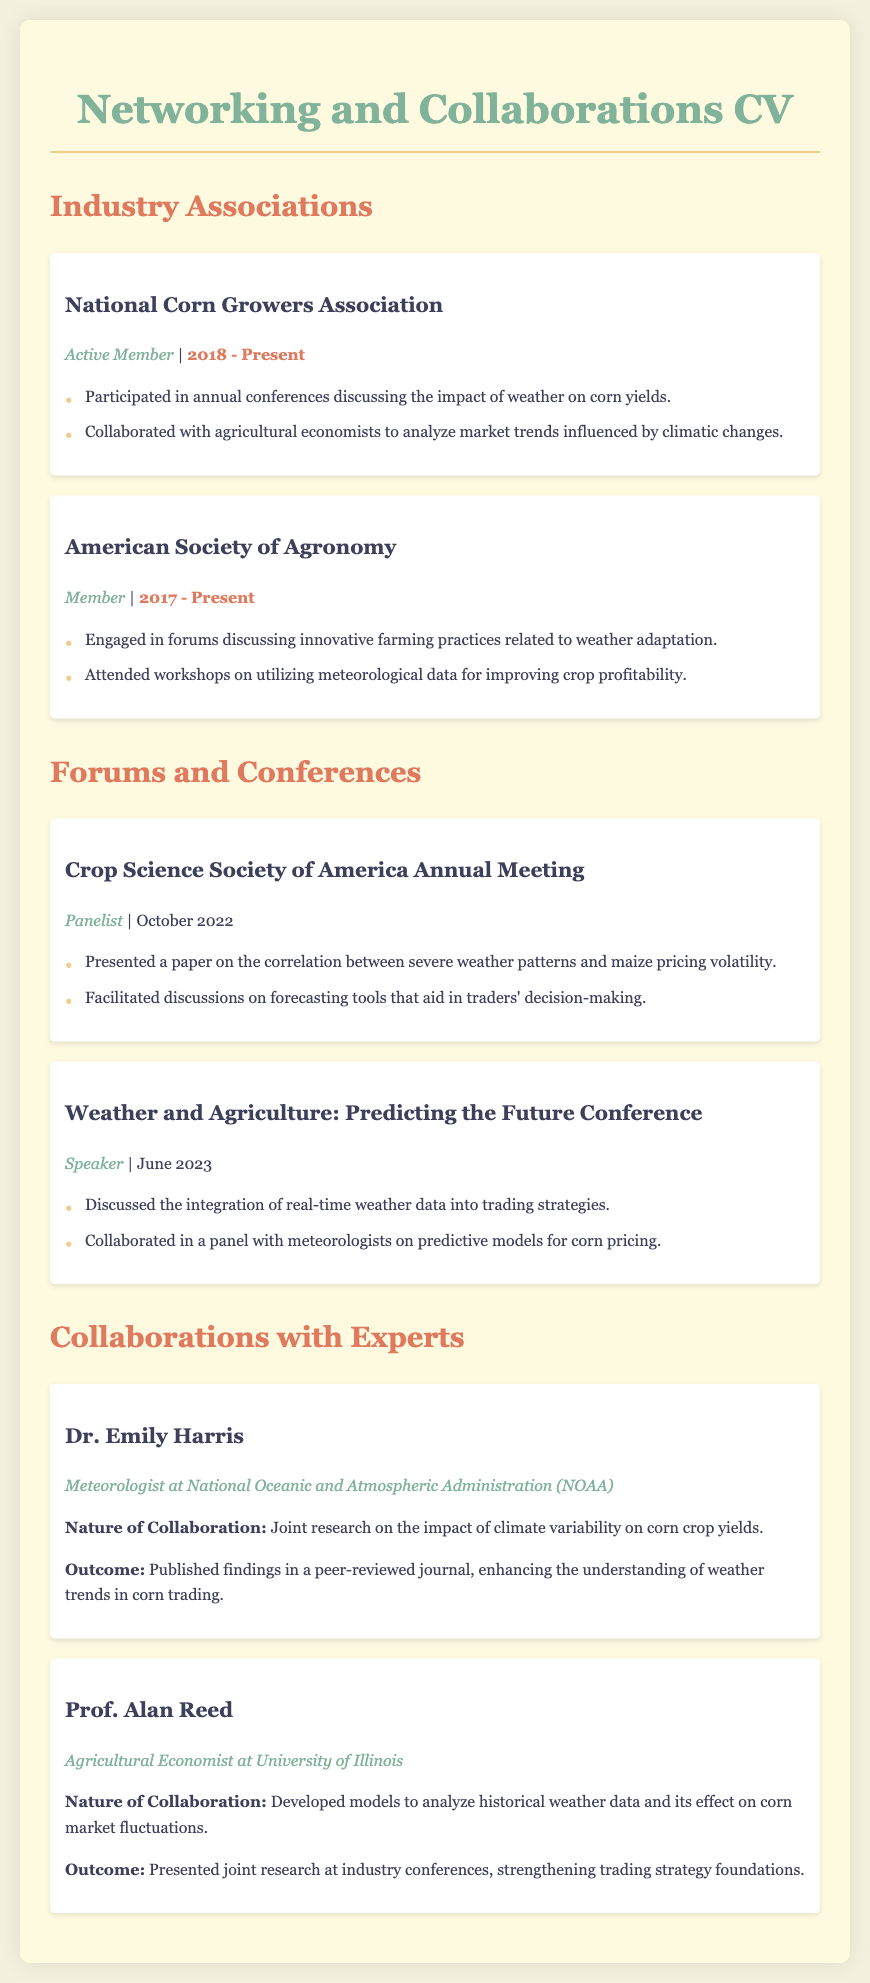What is the role of the individual in the National Corn Growers Association? The role in the National Corn Growers Association is listed as "Active Member."
Answer: Active Member When did participation as a member of the American Society of Agronomy begin? The member joined the American Society of Agronomy in 2017, which is indicated in the document.
Answer: 2017 What was the title of the paper presented at the Crop Science Society of America Annual Meeting? The document states that a paper was presented on the "correlation between severe weather patterns and maize pricing volatility."
Answer: correlation between severe weather patterns and maize pricing volatility Who is Dr. Emily Harris? Dr. Emily Harris is a "Meteorologist at National Oceanic and Atmospheric Administration (NOAA)."
Answer: Meteorologist at National Oceanic and Atmospheric Administration (NOAA) What was the nature of the collaboration with Prof. Alan Reed? The nature of the collaboration involved developing "models to analyze historical weather data and its effect on corn market fluctuations."
Answer: models to analyze historical weather data and its effect on corn market fluctuations In which month and year did the Weather and Agriculture Conference occur? The document states that the conference was held in June 2023.
Answer: June 2023 How many years has the individual been active with the National Corn Growers Association? The active membership started in 2018, and as of the current year, it accounts for 2023.
Answer: 5 years What is one outcome of collaborating with Dr. Emily Harris? One outcome mentioned is the "published findings in a peer-reviewed journal."
Answer: published findings in a peer-reviewed journal What is the title of the conference where a paper was discussed in June 2023? The title of the conference is "Weather and Agriculture: Predicting the Future Conference."
Answer: Weather and Agriculture: Predicting the Future Conference 